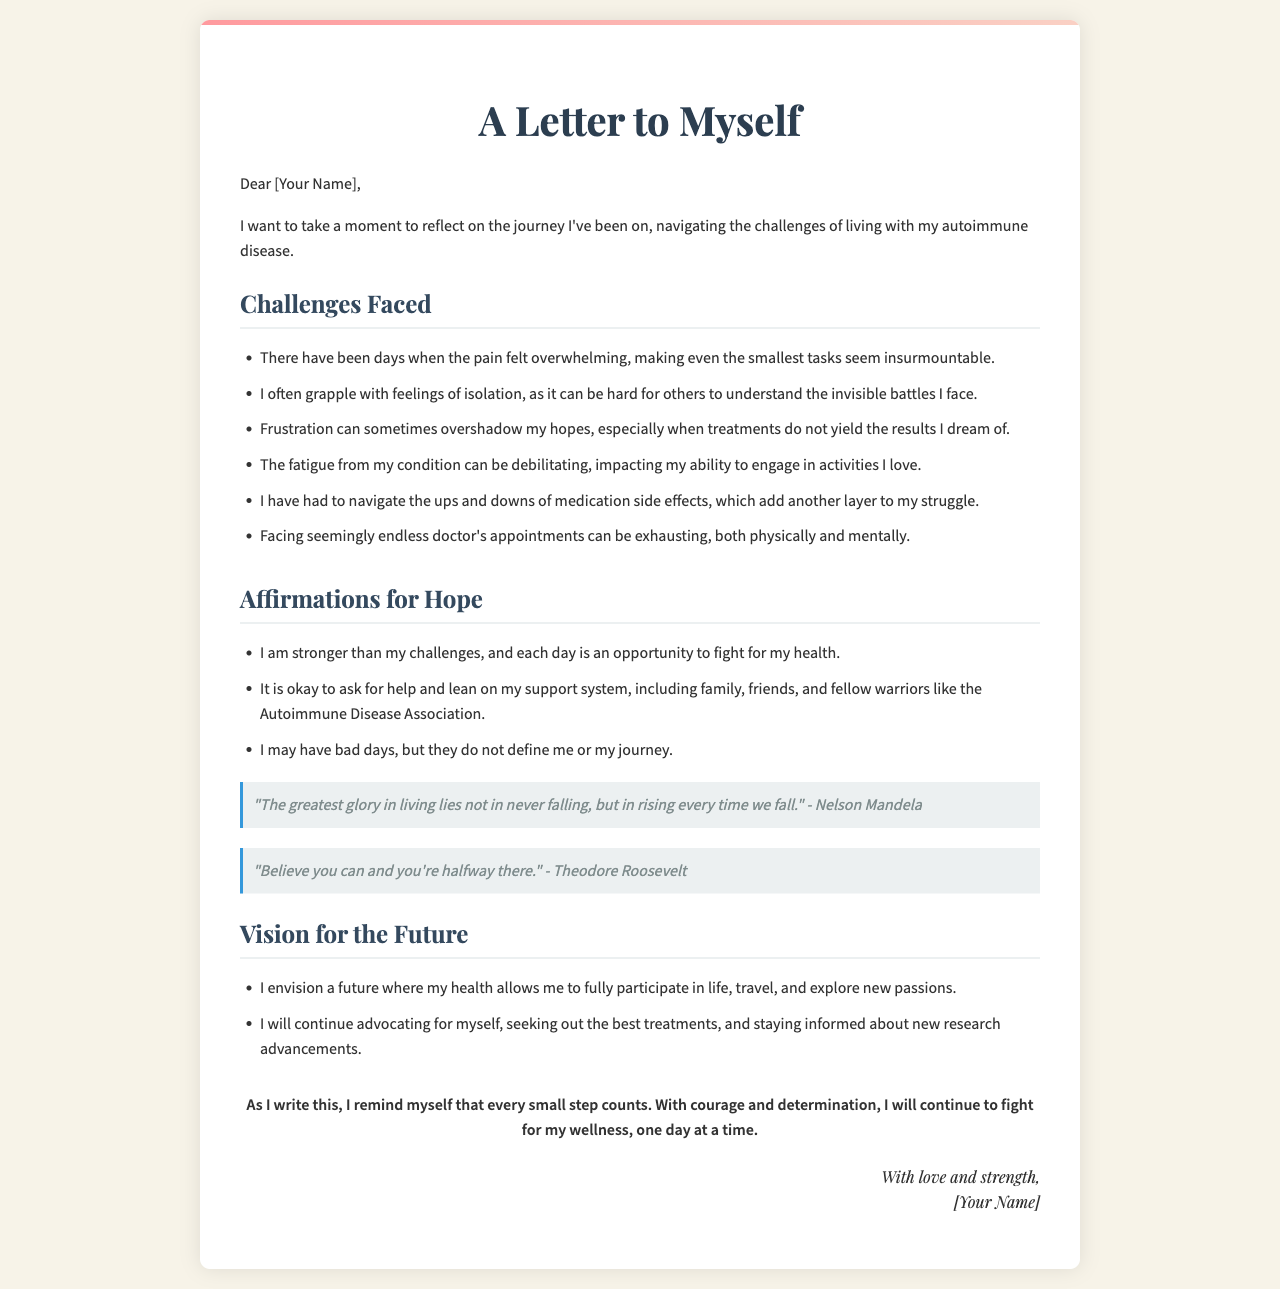What is the title of the letter? The title of the letter is stated at the beginning of the document.
Answer: A Letter to Myself How many challenges are listed? The document provides a bulleted list of challenges faced, and counting them gives the total.
Answer: 6 What is one of the affirmations for hope? The document includes several affirmations; one can be quoted directly from the list.
Answer: I am stronger than my challenges, and each day is an opportunity to fight for my health Who is quoted in the first quote? The first quote in the document attributes the saying to a specific individual.
Answer: Nelson Mandela What vision is described for the future? The document outlines a vision, which can be found in the section discussing future aspirations.
Answer: I envision a future where my health allows me to fully participate in life, travel, and explore new passions What feeling does the author sometimes grapple with? This feeling is mentioned as one of the challenges in the document.
Answer: Isolation How does the author remind herself to approach the journey? The conclusion of the letter contains an important reminder about living with determination.
Answer: Every small step counts What type of letter is this document categorized as? This describes the format and intention of the document.
Answer: An emotional letter to self 